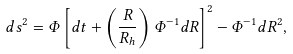Convert formula to latex. <formula><loc_0><loc_0><loc_500><loc_500>d s ^ { 2 } = \Phi \left [ d t + \left ( \frac { R } { R _ { h } } \right ) \Phi ^ { - 1 } d R \right ] ^ { 2 } - \Phi ^ { - 1 } d R ^ { 2 } ,</formula> 